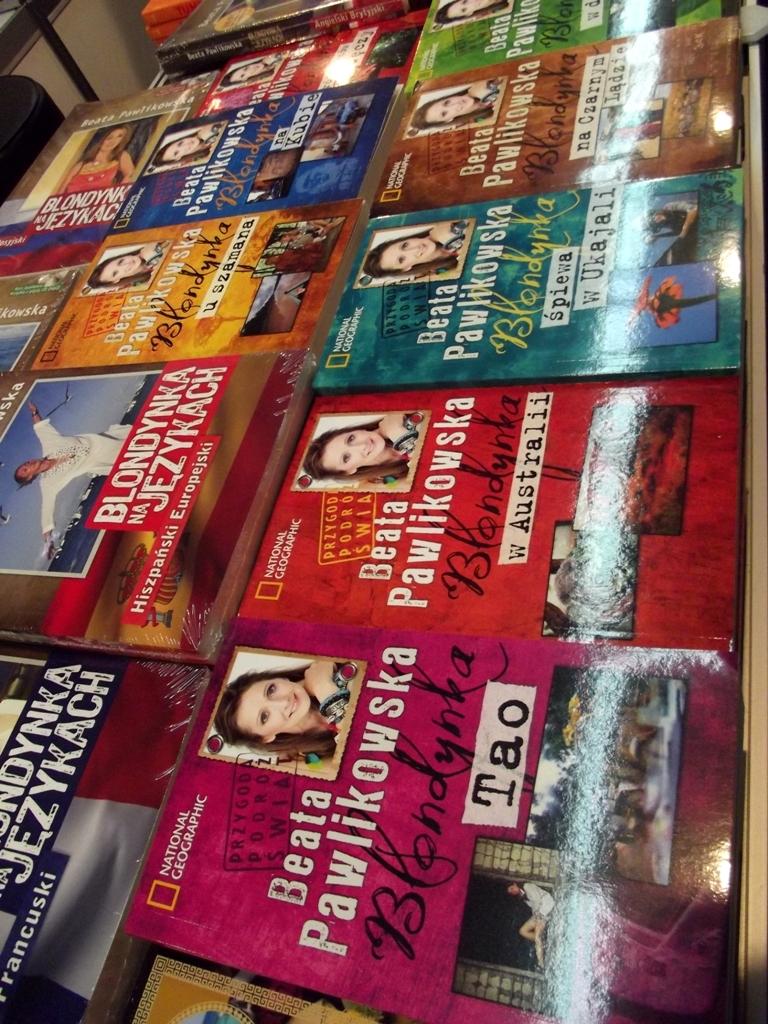What is the name of the purple travel book?
Your response must be concise. Tao. 